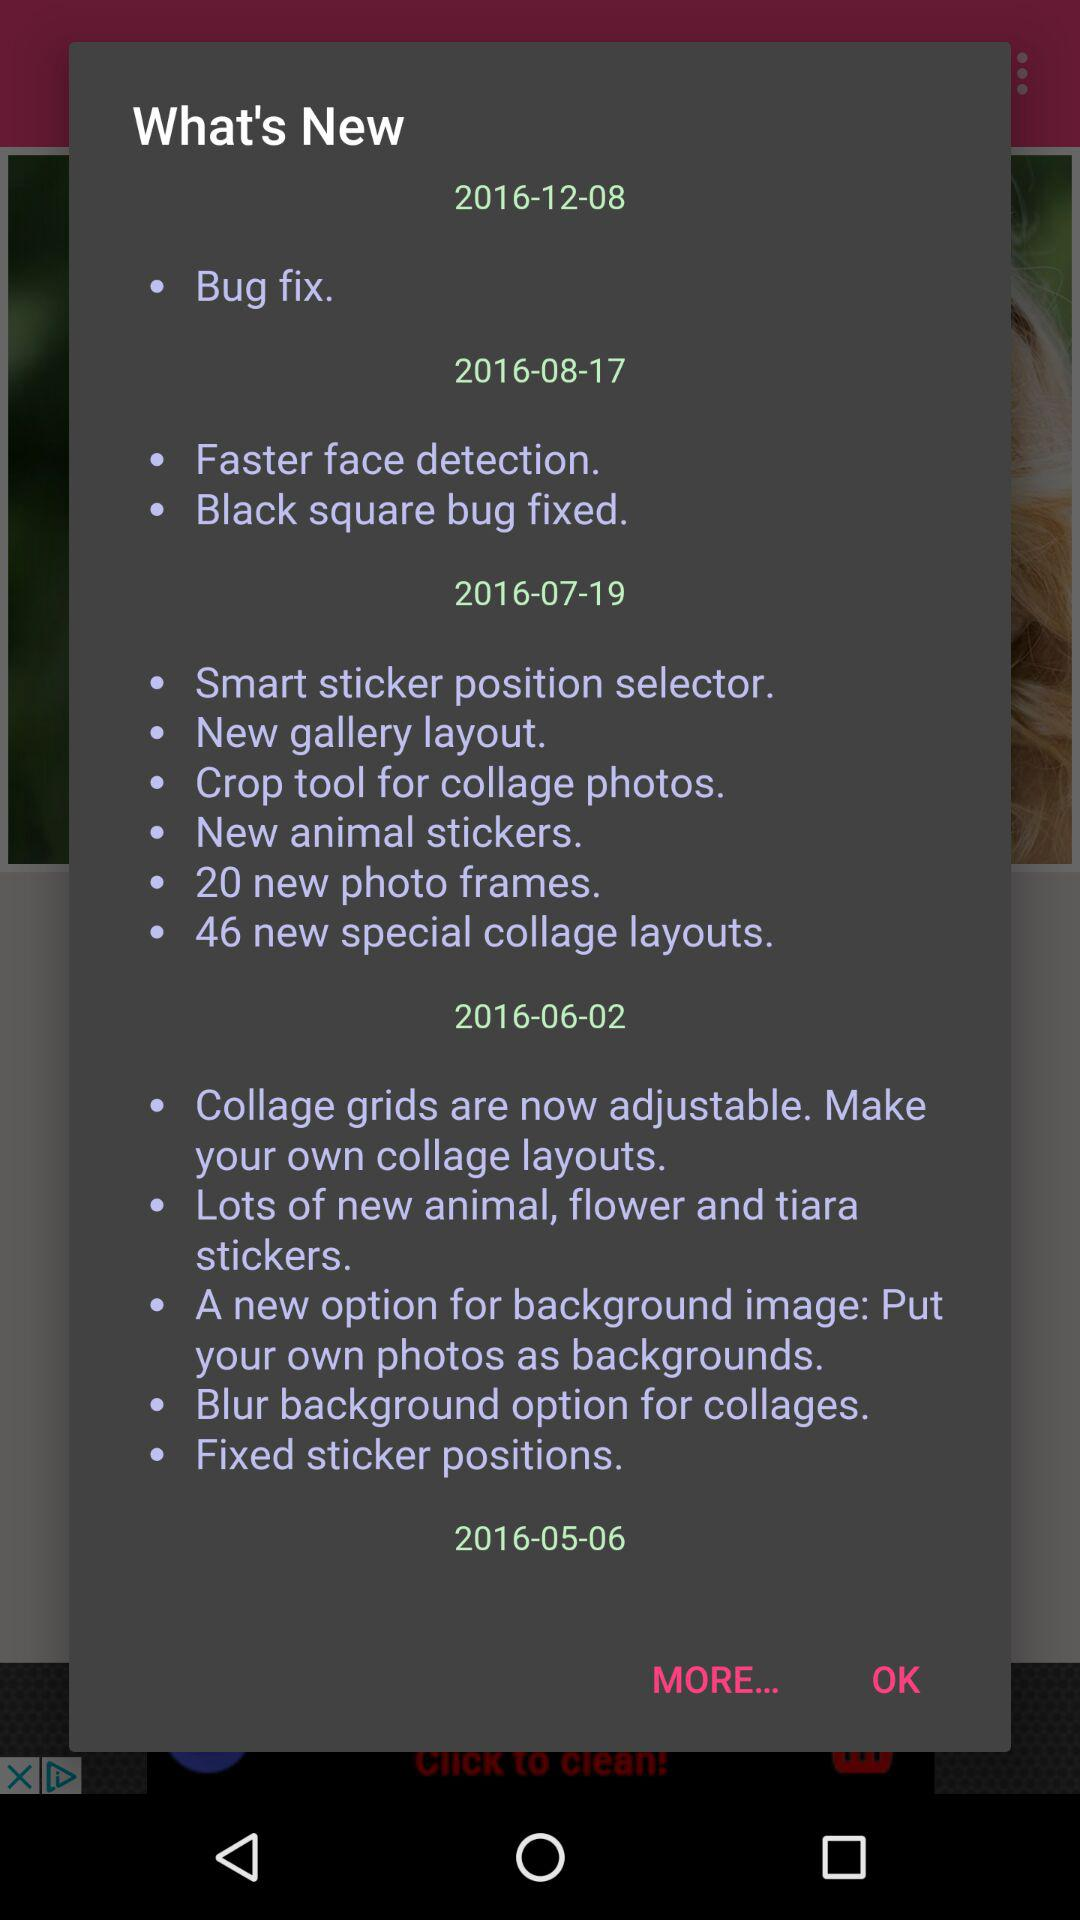What's new in 2016-08-17? There are two new features in 2016-08-17: "Faster face detection" and "Black square bug fixed". 